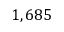<formula> <loc_0><loc_0><loc_500><loc_500>1 , 6 8 5</formula> 